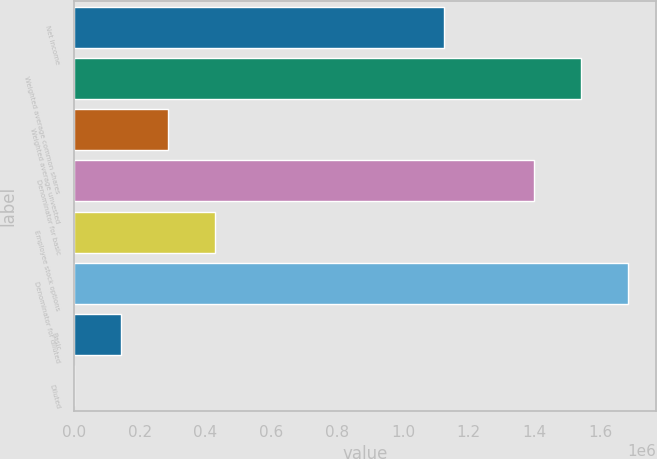Convert chart. <chart><loc_0><loc_0><loc_500><loc_500><bar_chart><fcel>Net income<fcel>Weighted average common shares<fcel>Weighted average unvested<fcel>Denominator for basic<fcel>Employee stock options<fcel>Denominator for diluted<fcel>Basic<fcel>Diluted<nl><fcel>1.12564e+06<fcel>1.5418e+06<fcel>285095<fcel>1.39925e+06<fcel>427642<fcel>1.68435e+06<fcel>142548<fcel>0.79<nl></chart> 